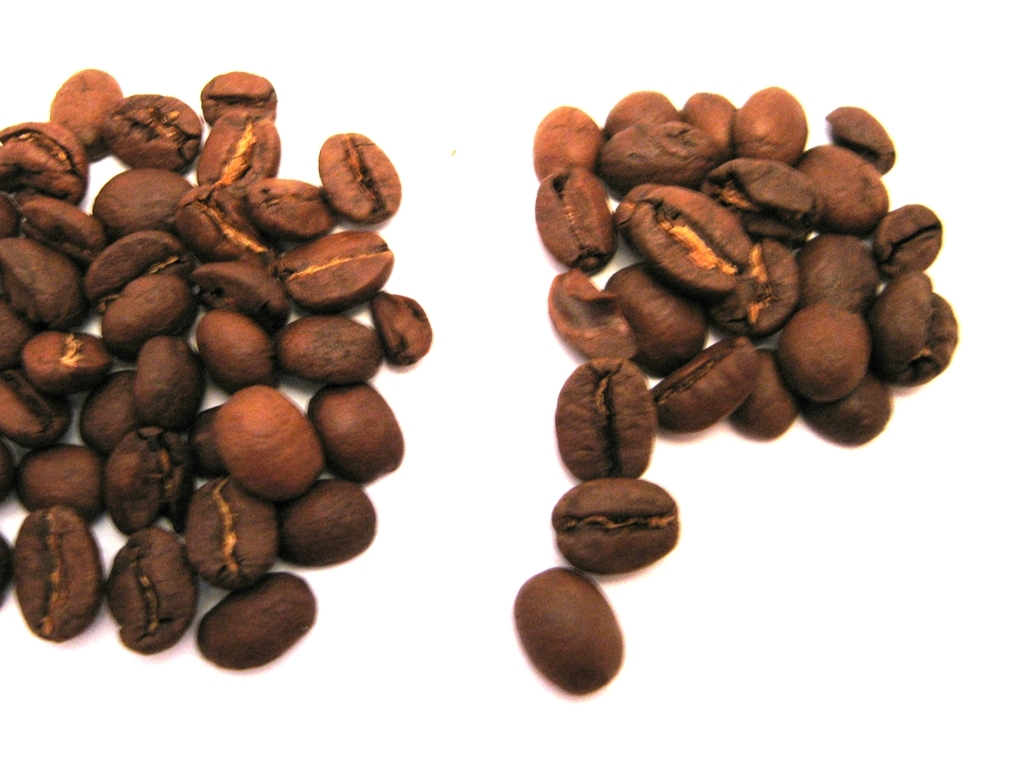What's the best way to store these coffee beans to maintain their freshness? To maintain their freshness, coffee beans should be stored in an airtight container away from light, heat, and moisture. A cool, dark place like a cabinet or pantry is ideal. Avoid storing them in the fridge or freezer as the fluctuating temperatures can cause condensation and affect the beans' quality. Is there a way to tell if coffee beans are fresh by looking at an image? An image can provide some clues about freshness, such as a glossy sheen on the beans indicating the presence of natural oils, which diminish as beans age. However, freshness is best determined by the aroma and flavor, which an image cannot convey. A recent roast date listed on a package is a reliable indicator of freshness. 